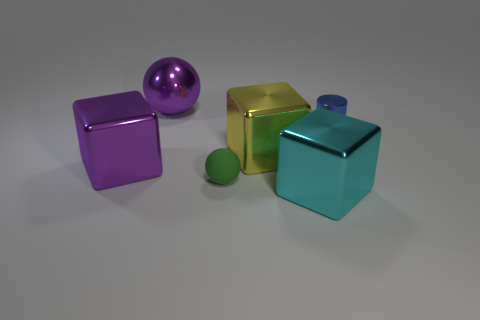Add 1 green balls. How many objects exist? 7 Subtract all balls. How many objects are left? 4 Add 4 tiny blue cylinders. How many tiny blue cylinders exist? 5 Subtract 0 blue spheres. How many objects are left? 6 Subtract all big objects. Subtract all yellow blocks. How many objects are left? 1 Add 2 large yellow blocks. How many large yellow blocks are left? 3 